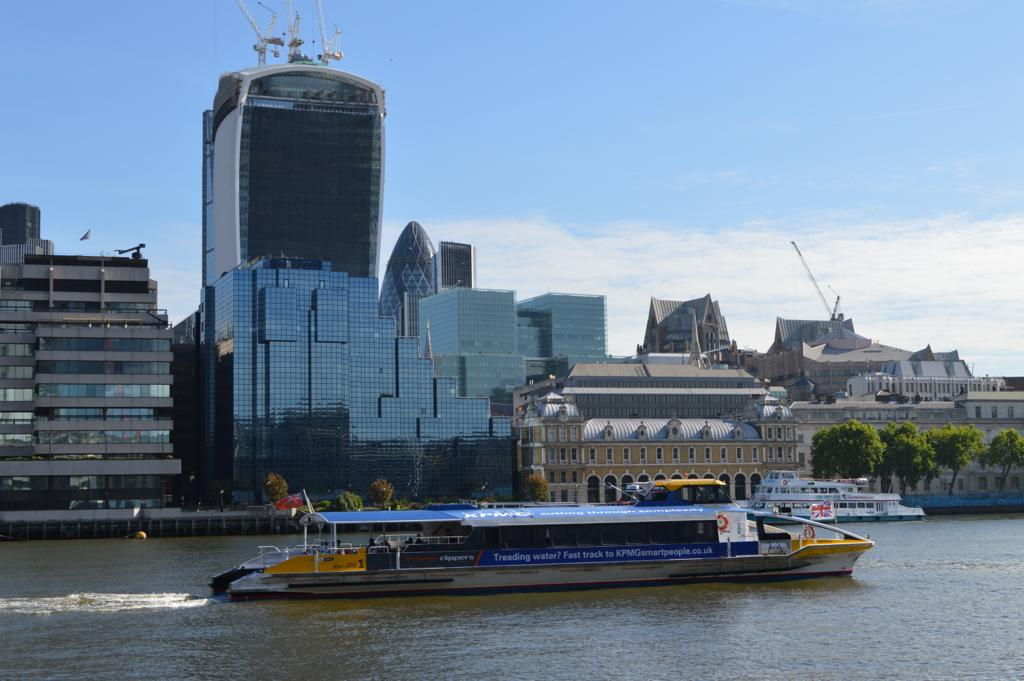What is the main subject of the image? The main subject of the image is a ship. Where is the ship located in the image? The ship is on the water. What can be seen in the background of the image? There are buildings and trees in the background of the image. What type of nose can be seen on the ship in the image? There is no nose present on the ship in the image. What is the ship carrying on its back in the image? Ships do not have backs, and there is no indication of any cargo being carried in the image. 